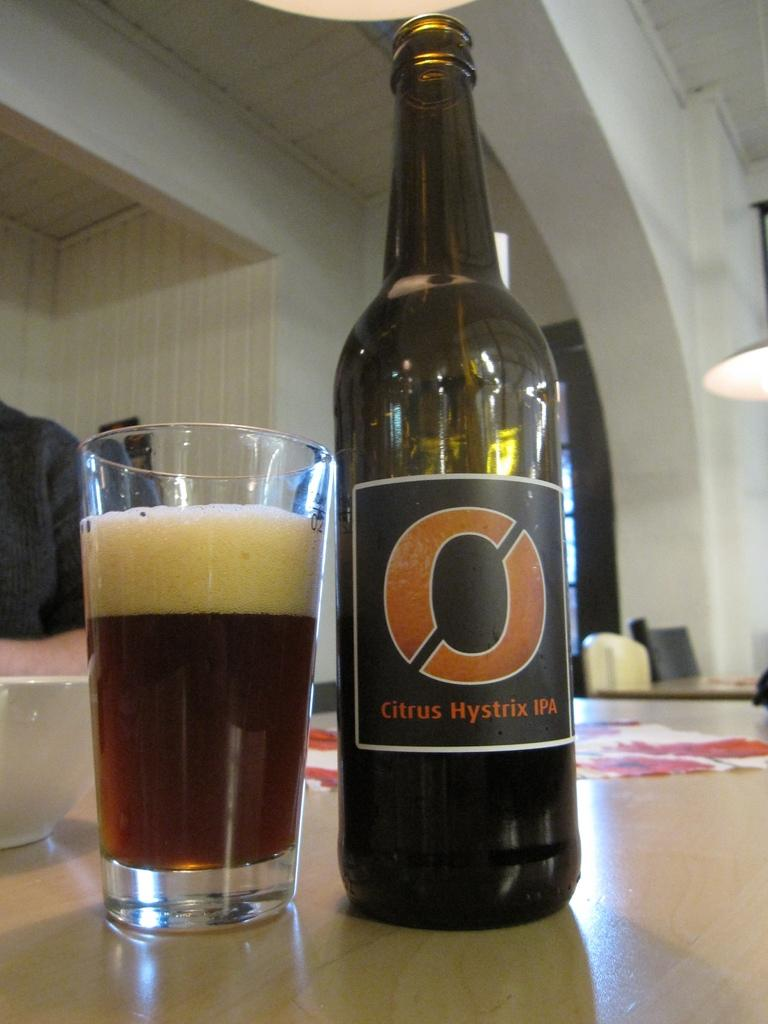<image>
Provide a brief description of the given image. A bottle of citrus hystrix IPA has a big O on the label. 